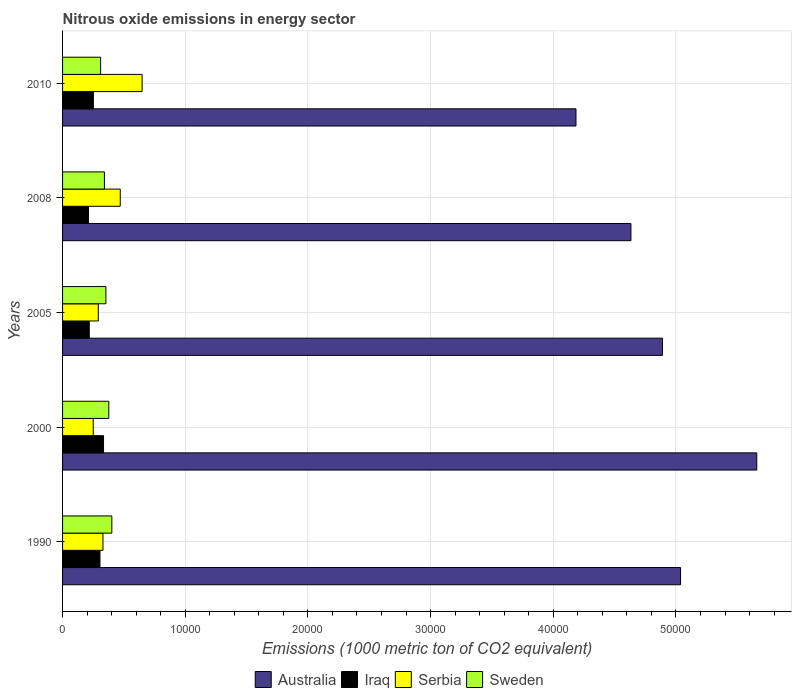Are the number of bars per tick equal to the number of legend labels?
Ensure brevity in your answer.  Yes. How many bars are there on the 4th tick from the bottom?
Keep it short and to the point. 4. What is the amount of nitrous oxide emitted in Sweden in 2000?
Ensure brevity in your answer.  3769. Across all years, what is the maximum amount of nitrous oxide emitted in Iraq?
Ensure brevity in your answer.  3339.1. Across all years, what is the minimum amount of nitrous oxide emitted in Serbia?
Give a very brief answer. 2501.4. In which year was the amount of nitrous oxide emitted in Iraq minimum?
Make the answer very short. 2008. What is the total amount of nitrous oxide emitted in Serbia in the graph?
Keep it short and to the point. 1.99e+04. What is the difference between the amount of nitrous oxide emitted in Serbia in 1990 and that in 2005?
Your answer should be compact. 380. What is the difference between the amount of nitrous oxide emitted in Serbia in 2010 and the amount of nitrous oxide emitted in Iraq in 2008?
Your answer should be very brief. 4369.5. What is the average amount of nitrous oxide emitted in Serbia per year?
Ensure brevity in your answer.  3979.06. In the year 2000, what is the difference between the amount of nitrous oxide emitted in Iraq and amount of nitrous oxide emitted in Sweden?
Make the answer very short. -429.9. In how many years, is the amount of nitrous oxide emitted in Sweden greater than 36000 1000 metric ton?
Provide a succinct answer. 0. What is the ratio of the amount of nitrous oxide emitted in Iraq in 2005 to that in 2008?
Your response must be concise. 1.03. Is the amount of nitrous oxide emitted in Iraq in 2005 less than that in 2010?
Ensure brevity in your answer.  Yes. What is the difference between the highest and the second highest amount of nitrous oxide emitted in Australia?
Ensure brevity in your answer.  6212.8. What is the difference between the highest and the lowest amount of nitrous oxide emitted in Sweden?
Your answer should be compact. 915.7. In how many years, is the amount of nitrous oxide emitted in Sweden greater than the average amount of nitrous oxide emitted in Sweden taken over all years?
Your answer should be very brief. 2. What does the 4th bar from the top in 2010 represents?
Offer a terse response. Australia. What does the 3rd bar from the bottom in 2000 represents?
Offer a very short reply. Serbia. Are all the bars in the graph horizontal?
Offer a very short reply. Yes. How many years are there in the graph?
Offer a terse response. 5. What is the difference between two consecutive major ticks on the X-axis?
Offer a very short reply. 10000. Are the values on the major ticks of X-axis written in scientific E-notation?
Offer a terse response. No. What is the title of the graph?
Offer a terse response. Nitrous oxide emissions in energy sector. What is the label or title of the X-axis?
Your answer should be very brief. Emissions (1000 metric ton of CO2 equivalent). What is the label or title of the Y-axis?
Offer a very short reply. Years. What is the Emissions (1000 metric ton of CO2 equivalent) of Australia in 1990?
Make the answer very short. 5.04e+04. What is the Emissions (1000 metric ton of CO2 equivalent) in Iraq in 1990?
Keep it short and to the point. 3048.6. What is the Emissions (1000 metric ton of CO2 equivalent) of Serbia in 1990?
Offer a very short reply. 3293.8. What is the Emissions (1000 metric ton of CO2 equivalent) of Sweden in 1990?
Your answer should be compact. 4016.7. What is the Emissions (1000 metric ton of CO2 equivalent) of Australia in 2000?
Provide a succinct answer. 5.66e+04. What is the Emissions (1000 metric ton of CO2 equivalent) of Iraq in 2000?
Give a very brief answer. 3339.1. What is the Emissions (1000 metric ton of CO2 equivalent) in Serbia in 2000?
Provide a short and direct response. 2501.4. What is the Emissions (1000 metric ton of CO2 equivalent) of Sweden in 2000?
Your answer should be compact. 3769. What is the Emissions (1000 metric ton of CO2 equivalent) of Australia in 2005?
Offer a very short reply. 4.89e+04. What is the Emissions (1000 metric ton of CO2 equivalent) in Iraq in 2005?
Provide a short and direct response. 2176. What is the Emissions (1000 metric ton of CO2 equivalent) of Serbia in 2005?
Your answer should be compact. 2913.8. What is the Emissions (1000 metric ton of CO2 equivalent) of Sweden in 2005?
Keep it short and to the point. 3533.4. What is the Emissions (1000 metric ton of CO2 equivalent) of Australia in 2008?
Your answer should be very brief. 4.63e+04. What is the Emissions (1000 metric ton of CO2 equivalent) of Iraq in 2008?
Keep it short and to the point. 2113.2. What is the Emissions (1000 metric ton of CO2 equivalent) of Serbia in 2008?
Give a very brief answer. 4703.6. What is the Emissions (1000 metric ton of CO2 equivalent) in Sweden in 2008?
Offer a terse response. 3412.4. What is the Emissions (1000 metric ton of CO2 equivalent) of Australia in 2010?
Ensure brevity in your answer.  4.19e+04. What is the Emissions (1000 metric ton of CO2 equivalent) in Iraq in 2010?
Offer a very short reply. 2512.5. What is the Emissions (1000 metric ton of CO2 equivalent) in Serbia in 2010?
Provide a succinct answer. 6482.7. What is the Emissions (1000 metric ton of CO2 equivalent) in Sweden in 2010?
Offer a terse response. 3101. Across all years, what is the maximum Emissions (1000 metric ton of CO2 equivalent) of Australia?
Offer a very short reply. 5.66e+04. Across all years, what is the maximum Emissions (1000 metric ton of CO2 equivalent) of Iraq?
Keep it short and to the point. 3339.1. Across all years, what is the maximum Emissions (1000 metric ton of CO2 equivalent) of Serbia?
Give a very brief answer. 6482.7. Across all years, what is the maximum Emissions (1000 metric ton of CO2 equivalent) in Sweden?
Ensure brevity in your answer.  4016.7. Across all years, what is the minimum Emissions (1000 metric ton of CO2 equivalent) of Australia?
Provide a succinct answer. 4.19e+04. Across all years, what is the minimum Emissions (1000 metric ton of CO2 equivalent) of Iraq?
Offer a terse response. 2113.2. Across all years, what is the minimum Emissions (1000 metric ton of CO2 equivalent) in Serbia?
Give a very brief answer. 2501.4. Across all years, what is the minimum Emissions (1000 metric ton of CO2 equivalent) of Sweden?
Offer a terse response. 3101. What is the total Emissions (1000 metric ton of CO2 equivalent) of Australia in the graph?
Keep it short and to the point. 2.44e+05. What is the total Emissions (1000 metric ton of CO2 equivalent) of Iraq in the graph?
Provide a succinct answer. 1.32e+04. What is the total Emissions (1000 metric ton of CO2 equivalent) of Serbia in the graph?
Keep it short and to the point. 1.99e+04. What is the total Emissions (1000 metric ton of CO2 equivalent) in Sweden in the graph?
Your answer should be very brief. 1.78e+04. What is the difference between the Emissions (1000 metric ton of CO2 equivalent) in Australia in 1990 and that in 2000?
Ensure brevity in your answer.  -6212.8. What is the difference between the Emissions (1000 metric ton of CO2 equivalent) of Iraq in 1990 and that in 2000?
Offer a very short reply. -290.5. What is the difference between the Emissions (1000 metric ton of CO2 equivalent) in Serbia in 1990 and that in 2000?
Keep it short and to the point. 792.4. What is the difference between the Emissions (1000 metric ton of CO2 equivalent) in Sweden in 1990 and that in 2000?
Provide a short and direct response. 247.7. What is the difference between the Emissions (1000 metric ton of CO2 equivalent) in Australia in 1990 and that in 2005?
Provide a succinct answer. 1475.2. What is the difference between the Emissions (1000 metric ton of CO2 equivalent) of Iraq in 1990 and that in 2005?
Your answer should be compact. 872.6. What is the difference between the Emissions (1000 metric ton of CO2 equivalent) in Serbia in 1990 and that in 2005?
Give a very brief answer. 380. What is the difference between the Emissions (1000 metric ton of CO2 equivalent) of Sweden in 1990 and that in 2005?
Provide a succinct answer. 483.3. What is the difference between the Emissions (1000 metric ton of CO2 equivalent) of Australia in 1990 and that in 2008?
Your answer should be compact. 4045.5. What is the difference between the Emissions (1000 metric ton of CO2 equivalent) of Iraq in 1990 and that in 2008?
Your answer should be compact. 935.4. What is the difference between the Emissions (1000 metric ton of CO2 equivalent) of Serbia in 1990 and that in 2008?
Provide a succinct answer. -1409.8. What is the difference between the Emissions (1000 metric ton of CO2 equivalent) of Sweden in 1990 and that in 2008?
Your answer should be very brief. 604.3. What is the difference between the Emissions (1000 metric ton of CO2 equivalent) in Australia in 1990 and that in 2010?
Your answer should be compact. 8525.4. What is the difference between the Emissions (1000 metric ton of CO2 equivalent) of Iraq in 1990 and that in 2010?
Your answer should be compact. 536.1. What is the difference between the Emissions (1000 metric ton of CO2 equivalent) of Serbia in 1990 and that in 2010?
Offer a very short reply. -3188.9. What is the difference between the Emissions (1000 metric ton of CO2 equivalent) of Sweden in 1990 and that in 2010?
Your response must be concise. 915.7. What is the difference between the Emissions (1000 metric ton of CO2 equivalent) of Australia in 2000 and that in 2005?
Offer a terse response. 7688. What is the difference between the Emissions (1000 metric ton of CO2 equivalent) in Iraq in 2000 and that in 2005?
Make the answer very short. 1163.1. What is the difference between the Emissions (1000 metric ton of CO2 equivalent) of Serbia in 2000 and that in 2005?
Keep it short and to the point. -412.4. What is the difference between the Emissions (1000 metric ton of CO2 equivalent) in Sweden in 2000 and that in 2005?
Make the answer very short. 235.6. What is the difference between the Emissions (1000 metric ton of CO2 equivalent) of Australia in 2000 and that in 2008?
Offer a terse response. 1.03e+04. What is the difference between the Emissions (1000 metric ton of CO2 equivalent) in Iraq in 2000 and that in 2008?
Your answer should be very brief. 1225.9. What is the difference between the Emissions (1000 metric ton of CO2 equivalent) of Serbia in 2000 and that in 2008?
Give a very brief answer. -2202.2. What is the difference between the Emissions (1000 metric ton of CO2 equivalent) of Sweden in 2000 and that in 2008?
Ensure brevity in your answer.  356.6. What is the difference between the Emissions (1000 metric ton of CO2 equivalent) of Australia in 2000 and that in 2010?
Offer a terse response. 1.47e+04. What is the difference between the Emissions (1000 metric ton of CO2 equivalent) in Iraq in 2000 and that in 2010?
Offer a terse response. 826.6. What is the difference between the Emissions (1000 metric ton of CO2 equivalent) in Serbia in 2000 and that in 2010?
Provide a succinct answer. -3981.3. What is the difference between the Emissions (1000 metric ton of CO2 equivalent) of Sweden in 2000 and that in 2010?
Provide a succinct answer. 668. What is the difference between the Emissions (1000 metric ton of CO2 equivalent) of Australia in 2005 and that in 2008?
Keep it short and to the point. 2570.3. What is the difference between the Emissions (1000 metric ton of CO2 equivalent) in Iraq in 2005 and that in 2008?
Provide a short and direct response. 62.8. What is the difference between the Emissions (1000 metric ton of CO2 equivalent) in Serbia in 2005 and that in 2008?
Make the answer very short. -1789.8. What is the difference between the Emissions (1000 metric ton of CO2 equivalent) in Sweden in 2005 and that in 2008?
Your answer should be very brief. 121. What is the difference between the Emissions (1000 metric ton of CO2 equivalent) in Australia in 2005 and that in 2010?
Provide a short and direct response. 7050.2. What is the difference between the Emissions (1000 metric ton of CO2 equivalent) in Iraq in 2005 and that in 2010?
Your response must be concise. -336.5. What is the difference between the Emissions (1000 metric ton of CO2 equivalent) in Serbia in 2005 and that in 2010?
Ensure brevity in your answer.  -3568.9. What is the difference between the Emissions (1000 metric ton of CO2 equivalent) in Sweden in 2005 and that in 2010?
Give a very brief answer. 432.4. What is the difference between the Emissions (1000 metric ton of CO2 equivalent) of Australia in 2008 and that in 2010?
Provide a short and direct response. 4479.9. What is the difference between the Emissions (1000 metric ton of CO2 equivalent) in Iraq in 2008 and that in 2010?
Offer a very short reply. -399.3. What is the difference between the Emissions (1000 metric ton of CO2 equivalent) of Serbia in 2008 and that in 2010?
Offer a very short reply. -1779.1. What is the difference between the Emissions (1000 metric ton of CO2 equivalent) of Sweden in 2008 and that in 2010?
Offer a terse response. 311.4. What is the difference between the Emissions (1000 metric ton of CO2 equivalent) in Australia in 1990 and the Emissions (1000 metric ton of CO2 equivalent) in Iraq in 2000?
Give a very brief answer. 4.70e+04. What is the difference between the Emissions (1000 metric ton of CO2 equivalent) in Australia in 1990 and the Emissions (1000 metric ton of CO2 equivalent) in Serbia in 2000?
Offer a very short reply. 4.79e+04. What is the difference between the Emissions (1000 metric ton of CO2 equivalent) in Australia in 1990 and the Emissions (1000 metric ton of CO2 equivalent) in Sweden in 2000?
Your response must be concise. 4.66e+04. What is the difference between the Emissions (1000 metric ton of CO2 equivalent) of Iraq in 1990 and the Emissions (1000 metric ton of CO2 equivalent) of Serbia in 2000?
Your answer should be compact. 547.2. What is the difference between the Emissions (1000 metric ton of CO2 equivalent) of Iraq in 1990 and the Emissions (1000 metric ton of CO2 equivalent) of Sweden in 2000?
Give a very brief answer. -720.4. What is the difference between the Emissions (1000 metric ton of CO2 equivalent) in Serbia in 1990 and the Emissions (1000 metric ton of CO2 equivalent) in Sweden in 2000?
Your response must be concise. -475.2. What is the difference between the Emissions (1000 metric ton of CO2 equivalent) in Australia in 1990 and the Emissions (1000 metric ton of CO2 equivalent) in Iraq in 2005?
Make the answer very short. 4.82e+04. What is the difference between the Emissions (1000 metric ton of CO2 equivalent) of Australia in 1990 and the Emissions (1000 metric ton of CO2 equivalent) of Serbia in 2005?
Keep it short and to the point. 4.75e+04. What is the difference between the Emissions (1000 metric ton of CO2 equivalent) of Australia in 1990 and the Emissions (1000 metric ton of CO2 equivalent) of Sweden in 2005?
Offer a very short reply. 4.68e+04. What is the difference between the Emissions (1000 metric ton of CO2 equivalent) of Iraq in 1990 and the Emissions (1000 metric ton of CO2 equivalent) of Serbia in 2005?
Ensure brevity in your answer.  134.8. What is the difference between the Emissions (1000 metric ton of CO2 equivalent) of Iraq in 1990 and the Emissions (1000 metric ton of CO2 equivalent) of Sweden in 2005?
Provide a short and direct response. -484.8. What is the difference between the Emissions (1000 metric ton of CO2 equivalent) in Serbia in 1990 and the Emissions (1000 metric ton of CO2 equivalent) in Sweden in 2005?
Your response must be concise. -239.6. What is the difference between the Emissions (1000 metric ton of CO2 equivalent) of Australia in 1990 and the Emissions (1000 metric ton of CO2 equivalent) of Iraq in 2008?
Make the answer very short. 4.83e+04. What is the difference between the Emissions (1000 metric ton of CO2 equivalent) of Australia in 1990 and the Emissions (1000 metric ton of CO2 equivalent) of Serbia in 2008?
Provide a short and direct response. 4.57e+04. What is the difference between the Emissions (1000 metric ton of CO2 equivalent) in Australia in 1990 and the Emissions (1000 metric ton of CO2 equivalent) in Sweden in 2008?
Provide a short and direct response. 4.70e+04. What is the difference between the Emissions (1000 metric ton of CO2 equivalent) of Iraq in 1990 and the Emissions (1000 metric ton of CO2 equivalent) of Serbia in 2008?
Provide a succinct answer. -1655. What is the difference between the Emissions (1000 metric ton of CO2 equivalent) in Iraq in 1990 and the Emissions (1000 metric ton of CO2 equivalent) in Sweden in 2008?
Your answer should be compact. -363.8. What is the difference between the Emissions (1000 metric ton of CO2 equivalent) in Serbia in 1990 and the Emissions (1000 metric ton of CO2 equivalent) in Sweden in 2008?
Your answer should be compact. -118.6. What is the difference between the Emissions (1000 metric ton of CO2 equivalent) in Australia in 1990 and the Emissions (1000 metric ton of CO2 equivalent) in Iraq in 2010?
Make the answer very short. 4.79e+04. What is the difference between the Emissions (1000 metric ton of CO2 equivalent) in Australia in 1990 and the Emissions (1000 metric ton of CO2 equivalent) in Serbia in 2010?
Give a very brief answer. 4.39e+04. What is the difference between the Emissions (1000 metric ton of CO2 equivalent) of Australia in 1990 and the Emissions (1000 metric ton of CO2 equivalent) of Sweden in 2010?
Make the answer very short. 4.73e+04. What is the difference between the Emissions (1000 metric ton of CO2 equivalent) in Iraq in 1990 and the Emissions (1000 metric ton of CO2 equivalent) in Serbia in 2010?
Your answer should be very brief. -3434.1. What is the difference between the Emissions (1000 metric ton of CO2 equivalent) in Iraq in 1990 and the Emissions (1000 metric ton of CO2 equivalent) in Sweden in 2010?
Your answer should be very brief. -52.4. What is the difference between the Emissions (1000 metric ton of CO2 equivalent) in Serbia in 1990 and the Emissions (1000 metric ton of CO2 equivalent) in Sweden in 2010?
Make the answer very short. 192.8. What is the difference between the Emissions (1000 metric ton of CO2 equivalent) in Australia in 2000 and the Emissions (1000 metric ton of CO2 equivalent) in Iraq in 2005?
Keep it short and to the point. 5.44e+04. What is the difference between the Emissions (1000 metric ton of CO2 equivalent) in Australia in 2000 and the Emissions (1000 metric ton of CO2 equivalent) in Serbia in 2005?
Provide a succinct answer. 5.37e+04. What is the difference between the Emissions (1000 metric ton of CO2 equivalent) in Australia in 2000 and the Emissions (1000 metric ton of CO2 equivalent) in Sweden in 2005?
Your answer should be very brief. 5.31e+04. What is the difference between the Emissions (1000 metric ton of CO2 equivalent) in Iraq in 2000 and the Emissions (1000 metric ton of CO2 equivalent) in Serbia in 2005?
Your response must be concise. 425.3. What is the difference between the Emissions (1000 metric ton of CO2 equivalent) in Iraq in 2000 and the Emissions (1000 metric ton of CO2 equivalent) in Sweden in 2005?
Provide a succinct answer. -194.3. What is the difference between the Emissions (1000 metric ton of CO2 equivalent) in Serbia in 2000 and the Emissions (1000 metric ton of CO2 equivalent) in Sweden in 2005?
Provide a short and direct response. -1032. What is the difference between the Emissions (1000 metric ton of CO2 equivalent) of Australia in 2000 and the Emissions (1000 metric ton of CO2 equivalent) of Iraq in 2008?
Provide a short and direct response. 5.45e+04. What is the difference between the Emissions (1000 metric ton of CO2 equivalent) in Australia in 2000 and the Emissions (1000 metric ton of CO2 equivalent) in Serbia in 2008?
Ensure brevity in your answer.  5.19e+04. What is the difference between the Emissions (1000 metric ton of CO2 equivalent) in Australia in 2000 and the Emissions (1000 metric ton of CO2 equivalent) in Sweden in 2008?
Keep it short and to the point. 5.32e+04. What is the difference between the Emissions (1000 metric ton of CO2 equivalent) in Iraq in 2000 and the Emissions (1000 metric ton of CO2 equivalent) in Serbia in 2008?
Offer a very short reply. -1364.5. What is the difference between the Emissions (1000 metric ton of CO2 equivalent) in Iraq in 2000 and the Emissions (1000 metric ton of CO2 equivalent) in Sweden in 2008?
Provide a short and direct response. -73.3. What is the difference between the Emissions (1000 metric ton of CO2 equivalent) in Serbia in 2000 and the Emissions (1000 metric ton of CO2 equivalent) in Sweden in 2008?
Ensure brevity in your answer.  -911. What is the difference between the Emissions (1000 metric ton of CO2 equivalent) of Australia in 2000 and the Emissions (1000 metric ton of CO2 equivalent) of Iraq in 2010?
Offer a very short reply. 5.41e+04. What is the difference between the Emissions (1000 metric ton of CO2 equivalent) of Australia in 2000 and the Emissions (1000 metric ton of CO2 equivalent) of Serbia in 2010?
Provide a succinct answer. 5.01e+04. What is the difference between the Emissions (1000 metric ton of CO2 equivalent) of Australia in 2000 and the Emissions (1000 metric ton of CO2 equivalent) of Sweden in 2010?
Your response must be concise. 5.35e+04. What is the difference between the Emissions (1000 metric ton of CO2 equivalent) of Iraq in 2000 and the Emissions (1000 metric ton of CO2 equivalent) of Serbia in 2010?
Ensure brevity in your answer.  -3143.6. What is the difference between the Emissions (1000 metric ton of CO2 equivalent) of Iraq in 2000 and the Emissions (1000 metric ton of CO2 equivalent) of Sweden in 2010?
Your response must be concise. 238.1. What is the difference between the Emissions (1000 metric ton of CO2 equivalent) of Serbia in 2000 and the Emissions (1000 metric ton of CO2 equivalent) of Sweden in 2010?
Provide a succinct answer. -599.6. What is the difference between the Emissions (1000 metric ton of CO2 equivalent) in Australia in 2005 and the Emissions (1000 metric ton of CO2 equivalent) in Iraq in 2008?
Offer a terse response. 4.68e+04. What is the difference between the Emissions (1000 metric ton of CO2 equivalent) of Australia in 2005 and the Emissions (1000 metric ton of CO2 equivalent) of Serbia in 2008?
Make the answer very short. 4.42e+04. What is the difference between the Emissions (1000 metric ton of CO2 equivalent) in Australia in 2005 and the Emissions (1000 metric ton of CO2 equivalent) in Sweden in 2008?
Your answer should be compact. 4.55e+04. What is the difference between the Emissions (1000 metric ton of CO2 equivalent) in Iraq in 2005 and the Emissions (1000 metric ton of CO2 equivalent) in Serbia in 2008?
Offer a terse response. -2527.6. What is the difference between the Emissions (1000 metric ton of CO2 equivalent) of Iraq in 2005 and the Emissions (1000 metric ton of CO2 equivalent) of Sweden in 2008?
Provide a short and direct response. -1236.4. What is the difference between the Emissions (1000 metric ton of CO2 equivalent) of Serbia in 2005 and the Emissions (1000 metric ton of CO2 equivalent) of Sweden in 2008?
Offer a very short reply. -498.6. What is the difference between the Emissions (1000 metric ton of CO2 equivalent) of Australia in 2005 and the Emissions (1000 metric ton of CO2 equivalent) of Iraq in 2010?
Provide a succinct answer. 4.64e+04. What is the difference between the Emissions (1000 metric ton of CO2 equivalent) in Australia in 2005 and the Emissions (1000 metric ton of CO2 equivalent) in Serbia in 2010?
Offer a terse response. 4.24e+04. What is the difference between the Emissions (1000 metric ton of CO2 equivalent) in Australia in 2005 and the Emissions (1000 metric ton of CO2 equivalent) in Sweden in 2010?
Keep it short and to the point. 4.58e+04. What is the difference between the Emissions (1000 metric ton of CO2 equivalent) in Iraq in 2005 and the Emissions (1000 metric ton of CO2 equivalent) in Serbia in 2010?
Keep it short and to the point. -4306.7. What is the difference between the Emissions (1000 metric ton of CO2 equivalent) of Iraq in 2005 and the Emissions (1000 metric ton of CO2 equivalent) of Sweden in 2010?
Offer a very short reply. -925. What is the difference between the Emissions (1000 metric ton of CO2 equivalent) in Serbia in 2005 and the Emissions (1000 metric ton of CO2 equivalent) in Sweden in 2010?
Provide a succinct answer. -187.2. What is the difference between the Emissions (1000 metric ton of CO2 equivalent) in Australia in 2008 and the Emissions (1000 metric ton of CO2 equivalent) in Iraq in 2010?
Your answer should be very brief. 4.38e+04. What is the difference between the Emissions (1000 metric ton of CO2 equivalent) of Australia in 2008 and the Emissions (1000 metric ton of CO2 equivalent) of Serbia in 2010?
Your answer should be compact. 3.98e+04. What is the difference between the Emissions (1000 metric ton of CO2 equivalent) in Australia in 2008 and the Emissions (1000 metric ton of CO2 equivalent) in Sweden in 2010?
Offer a very short reply. 4.32e+04. What is the difference between the Emissions (1000 metric ton of CO2 equivalent) in Iraq in 2008 and the Emissions (1000 metric ton of CO2 equivalent) in Serbia in 2010?
Provide a succinct answer. -4369.5. What is the difference between the Emissions (1000 metric ton of CO2 equivalent) in Iraq in 2008 and the Emissions (1000 metric ton of CO2 equivalent) in Sweden in 2010?
Keep it short and to the point. -987.8. What is the difference between the Emissions (1000 metric ton of CO2 equivalent) in Serbia in 2008 and the Emissions (1000 metric ton of CO2 equivalent) in Sweden in 2010?
Provide a short and direct response. 1602.6. What is the average Emissions (1000 metric ton of CO2 equivalent) in Australia per year?
Offer a terse response. 4.88e+04. What is the average Emissions (1000 metric ton of CO2 equivalent) of Iraq per year?
Make the answer very short. 2637.88. What is the average Emissions (1000 metric ton of CO2 equivalent) in Serbia per year?
Make the answer very short. 3979.06. What is the average Emissions (1000 metric ton of CO2 equivalent) of Sweden per year?
Make the answer very short. 3566.5. In the year 1990, what is the difference between the Emissions (1000 metric ton of CO2 equivalent) of Australia and Emissions (1000 metric ton of CO2 equivalent) of Iraq?
Your answer should be very brief. 4.73e+04. In the year 1990, what is the difference between the Emissions (1000 metric ton of CO2 equivalent) in Australia and Emissions (1000 metric ton of CO2 equivalent) in Serbia?
Offer a very short reply. 4.71e+04. In the year 1990, what is the difference between the Emissions (1000 metric ton of CO2 equivalent) of Australia and Emissions (1000 metric ton of CO2 equivalent) of Sweden?
Offer a terse response. 4.64e+04. In the year 1990, what is the difference between the Emissions (1000 metric ton of CO2 equivalent) in Iraq and Emissions (1000 metric ton of CO2 equivalent) in Serbia?
Ensure brevity in your answer.  -245.2. In the year 1990, what is the difference between the Emissions (1000 metric ton of CO2 equivalent) in Iraq and Emissions (1000 metric ton of CO2 equivalent) in Sweden?
Offer a terse response. -968.1. In the year 1990, what is the difference between the Emissions (1000 metric ton of CO2 equivalent) in Serbia and Emissions (1000 metric ton of CO2 equivalent) in Sweden?
Your answer should be very brief. -722.9. In the year 2000, what is the difference between the Emissions (1000 metric ton of CO2 equivalent) in Australia and Emissions (1000 metric ton of CO2 equivalent) in Iraq?
Make the answer very short. 5.33e+04. In the year 2000, what is the difference between the Emissions (1000 metric ton of CO2 equivalent) of Australia and Emissions (1000 metric ton of CO2 equivalent) of Serbia?
Give a very brief answer. 5.41e+04. In the year 2000, what is the difference between the Emissions (1000 metric ton of CO2 equivalent) in Australia and Emissions (1000 metric ton of CO2 equivalent) in Sweden?
Make the answer very short. 5.28e+04. In the year 2000, what is the difference between the Emissions (1000 metric ton of CO2 equivalent) in Iraq and Emissions (1000 metric ton of CO2 equivalent) in Serbia?
Offer a very short reply. 837.7. In the year 2000, what is the difference between the Emissions (1000 metric ton of CO2 equivalent) in Iraq and Emissions (1000 metric ton of CO2 equivalent) in Sweden?
Give a very brief answer. -429.9. In the year 2000, what is the difference between the Emissions (1000 metric ton of CO2 equivalent) of Serbia and Emissions (1000 metric ton of CO2 equivalent) of Sweden?
Provide a succinct answer. -1267.6. In the year 2005, what is the difference between the Emissions (1000 metric ton of CO2 equivalent) of Australia and Emissions (1000 metric ton of CO2 equivalent) of Iraq?
Give a very brief answer. 4.67e+04. In the year 2005, what is the difference between the Emissions (1000 metric ton of CO2 equivalent) in Australia and Emissions (1000 metric ton of CO2 equivalent) in Serbia?
Offer a very short reply. 4.60e+04. In the year 2005, what is the difference between the Emissions (1000 metric ton of CO2 equivalent) in Australia and Emissions (1000 metric ton of CO2 equivalent) in Sweden?
Give a very brief answer. 4.54e+04. In the year 2005, what is the difference between the Emissions (1000 metric ton of CO2 equivalent) of Iraq and Emissions (1000 metric ton of CO2 equivalent) of Serbia?
Make the answer very short. -737.8. In the year 2005, what is the difference between the Emissions (1000 metric ton of CO2 equivalent) of Iraq and Emissions (1000 metric ton of CO2 equivalent) of Sweden?
Your answer should be very brief. -1357.4. In the year 2005, what is the difference between the Emissions (1000 metric ton of CO2 equivalent) in Serbia and Emissions (1000 metric ton of CO2 equivalent) in Sweden?
Ensure brevity in your answer.  -619.6. In the year 2008, what is the difference between the Emissions (1000 metric ton of CO2 equivalent) of Australia and Emissions (1000 metric ton of CO2 equivalent) of Iraq?
Provide a short and direct response. 4.42e+04. In the year 2008, what is the difference between the Emissions (1000 metric ton of CO2 equivalent) of Australia and Emissions (1000 metric ton of CO2 equivalent) of Serbia?
Offer a terse response. 4.16e+04. In the year 2008, what is the difference between the Emissions (1000 metric ton of CO2 equivalent) in Australia and Emissions (1000 metric ton of CO2 equivalent) in Sweden?
Give a very brief answer. 4.29e+04. In the year 2008, what is the difference between the Emissions (1000 metric ton of CO2 equivalent) in Iraq and Emissions (1000 metric ton of CO2 equivalent) in Serbia?
Provide a short and direct response. -2590.4. In the year 2008, what is the difference between the Emissions (1000 metric ton of CO2 equivalent) in Iraq and Emissions (1000 metric ton of CO2 equivalent) in Sweden?
Provide a short and direct response. -1299.2. In the year 2008, what is the difference between the Emissions (1000 metric ton of CO2 equivalent) in Serbia and Emissions (1000 metric ton of CO2 equivalent) in Sweden?
Ensure brevity in your answer.  1291.2. In the year 2010, what is the difference between the Emissions (1000 metric ton of CO2 equivalent) in Australia and Emissions (1000 metric ton of CO2 equivalent) in Iraq?
Offer a very short reply. 3.93e+04. In the year 2010, what is the difference between the Emissions (1000 metric ton of CO2 equivalent) in Australia and Emissions (1000 metric ton of CO2 equivalent) in Serbia?
Your answer should be compact. 3.54e+04. In the year 2010, what is the difference between the Emissions (1000 metric ton of CO2 equivalent) of Australia and Emissions (1000 metric ton of CO2 equivalent) of Sweden?
Make the answer very short. 3.88e+04. In the year 2010, what is the difference between the Emissions (1000 metric ton of CO2 equivalent) in Iraq and Emissions (1000 metric ton of CO2 equivalent) in Serbia?
Your answer should be compact. -3970.2. In the year 2010, what is the difference between the Emissions (1000 metric ton of CO2 equivalent) of Iraq and Emissions (1000 metric ton of CO2 equivalent) of Sweden?
Give a very brief answer. -588.5. In the year 2010, what is the difference between the Emissions (1000 metric ton of CO2 equivalent) of Serbia and Emissions (1000 metric ton of CO2 equivalent) of Sweden?
Your answer should be very brief. 3381.7. What is the ratio of the Emissions (1000 metric ton of CO2 equivalent) of Australia in 1990 to that in 2000?
Your answer should be very brief. 0.89. What is the ratio of the Emissions (1000 metric ton of CO2 equivalent) in Iraq in 1990 to that in 2000?
Your response must be concise. 0.91. What is the ratio of the Emissions (1000 metric ton of CO2 equivalent) in Serbia in 1990 to that in 2000?
Offer a very short reply. 1.32. What is the ratio of the Emissions (1000 metric ton of CO2 equivalent) of Sweden in 1990 to that in 2000?
Give a very brief answer. 1.07. What is the ratio of the Emissions (1000 metric ton of CO2 equivalent) in Australia in 1990 to that in 2005?
Your answer should be very brief. 1.03. What is the ratio of the Emissions (1000 metric ton of CO2 equivalent) in Iraq in 1990 to that in 2005?
Ensure brevity in your answer.  1.4. What is the ratio of the Emissions (1000 metric ton of CO2 equivalent) in Serbia in 1990 to that in 2005?
Give a very brief answer. 1.13. What is the ratio of the Emissions (1000 metric ton of CO2 equivalent) of Sweden in 1990 to that in 2005?
Ensure brevity in your answer.  1.14. What is the ratio of the Emissions (1000 metric ton of CO2 equivalent) of Australia in 1990 to that in 2008?
Ensure brevity in your answer.  1.09. What is the ratio of the Emissions (1000 metric ton of CO2 equivalent) of Iraq in 1990 to that in 2008?
Your answer should be very brief. 1.44. What is the ratio of the Emissions (1000 metric ton of CO2 equivalent) in Serbia in 1990 to that in 2008?
Offer a very short reply. 0.7. What is the ratio of the Emissions (1000 metric ton of CO2 equivalent) of Sweden in 1990 to that in 2008?
Give a very brief answer. 1.18. What is the ratio of the Emissions (1000 metric ton of CO2 equivalent) in Australia in 1990 to that in 2010?
Ensure brevity in your answer.  1.2. What is the ratio of the Emissions (1000 metric ton of CO2 equivalent) in Iraq in 1990 to that in 2010?
Offer a terse response. 1.21. What is the ratio of the Emissions (1000 metric ton of CO2 equivalent) of Serbia in 1990 to that in 2010?
Offer a very short reply. 0.51. What is the ratio of the Emissions (1000 metric ton of CO2 equivalent) of Sweden in 1990 to that in 2010?
Your answer should be very brief. 1.3. What is the ratio of the Emissions (1000 metric ton of CO2 equivalent) in Australia in 2000 to that in 2005?
Offer a terse response. 1.16. What is the ratio of the Emissions (1000 metric ton of CO2 equivalent) of Iraq in 2000 to that in 2005?
Offer a very short reply. 1.53. What is the ratio of the Emissions (1000 metric ton of CO2 equivalent) of Serbia in 2000 to that in 2005?
Your answer should be very brief. 0.86. What is the ratio of the Emissions (1000 metric ton of CO2 equivalent) in Sweden in 2000 to that in 2005?
Provide a short and direct response. 1.07. What is the ratio of the Emissions (1000 metric ton of CO2 equivalent) in Australia in 2000 to that in 2008?
Your answer should be very brief. 1.22. What is the ratio of the Emissions (1000 metric ton of CO2 equivalent) in Iraq in 2000 to that in 2008?
Offer a terse response. 1.58. What is the ratio of the Emissions (1000 metric ton of CO2 equivalent) in Serbia in 2000 to that in 2008?
Your answer should be very brief. 0.53. What is the ratio of the Emissions (1000 metric ton of CO2 equivalent) of Sweden in 2000 to that in 2008?
Your answer should be compact. 1.1. What is the ratio of the Emissions (1000 metric ton of CO2 equivalent) in Australia in 2000 to that in 2010?
Give a very brief answer. 1.35. What is the ratio of the Emissions (1000 metric ton of CO2 equivalent) in Iraq in 2000 to that in 2010?
Give a very brief answer. 1.33. What is the ratio of the Emissions (1000 metric ton of CO2 equivalent) of Serbia in 2000 to that in 2010?
Ensure brevity in your answer.  0.39. What is the ratio of the Emissions (1000 metric ton of CO2 equivalent) of Sweden in 2000 to that in 2010?
Your answer should be compact. 1.22. What is the ratio of the Emissions (1000 metric ton of CO2 equivalent) in Australia in 2005 to that in 2008?
Provide a short and direct response. 1.06. What is the ratio of the Emissions (1000 metric ton of CO2 equivalent) of Iraq in 2005 to that in 2008?
Ensure brevity in your answer.  1.03. What is the ratio of the Emissions (1000 metric ton of CO2 equivalent) in Serbia in 2005 to that in 2008?
Provide a short and direct response. 0.62. What is the ratio of the Emissions (1000 metric ton of CO2 equivalent) of Sweden in 2005 to that in 2008?
Your answer should be very brief. 1.04. What is the ratio of the Emissions (1000 metric ton of CO2 equivalent) of Australia in 2005 to that in 2010?
Your answer should be very brief. 1.17. What is the ratio of the Emissions (1000 metric ton of CO2 equivalent) in Iraq in 2005 to that in 2010?
Provide a short and direct response. 0.87. What is the ratio of the Emissions (1000 metric ton of CO2 equivalent) in Serbia in 2005 to that in 2010?
Your answer should be very brief. 0.45. What is the ratio of the Emissions (1000 metric ton of CO2 equivalent) in Sweden in 2005 to that in 2010?
Make the answer very short. 1.14. What is the ratio of the Emissions (1000 metric ton of CO2 equivalent) of Australia in 2008 to that in 2010?
Keep it short and to the point. 1.11. What is the ratio of the Emissions (1000 metric ton of CO2 equivalent) of Iraq in 2008 to that in 2010?
Provide a succinct answer. 0.84. What is the ratio of the Emissions (1000 metric ton of CO2 equivalent) in Serbia in 2008 to that in 2010?
Your answer should be very brief. 0.73. What is the ratio of the Emissions (1000 metric ton of CO2 equivalent) in Sweden in 2008 to that in 2010?
Offer a very short reply. 1.1. What is the difference between the highest and the second highest Emissions (1000 metric ton of CO2 equivalent) in Australia?
Provide a succinct answer. 6212.8. What is the difference between the highest and the second highest Emissions (1000 metric ton of CO2 equivalent) in Iraq?
Give a very brief answer. 290.5. What is the difference between the highest and the second highest Emissions (1000 metric ton of CO2 equivalent) of Serbia?
Offer a terse response. 1779.1. What is the difference between the highest and the second highest Emissions (1000 metric ton of CO2 equivalent) of Sweden?
Provide a succinct answer. 247.7. What is the difference between the highest and the lowest Emissions (1000 metric ton of CO2 equivalent) of Australia?
Your answer should be very brief. 1.47e+04. What is the difference between the highest and the lowest Emissions (1000 metric ton of CO2 equivalent) in Iraq?
Offer a terse response. 1225.9. What is the difference between the highest and the lowest Emissions (1000 metric ton of CO2 equivalent) in Serbia?
Offer a terse response. 3981.3. What is the difference between the highest and the lowest Emissions (1000 metric ton of CO2 equivalent) in Sweden?
Your response must be concise. 915.7. 